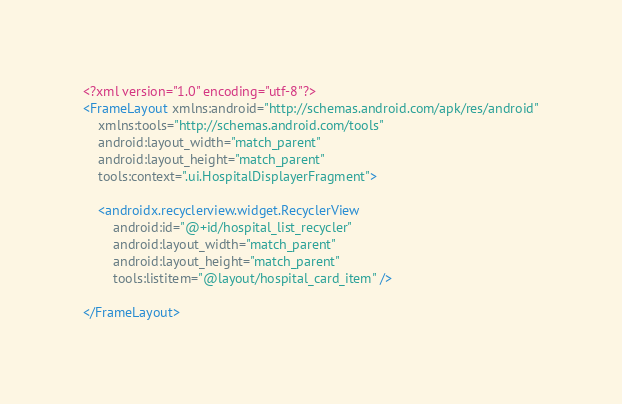Convert code to text. <code><loc_0><loc_0><loc_500><loc_500><_XML_><?xml version="1.0" encoding="utf-8"?>
<FrameLayout xmlns:android="http://schemas.android.com/apk/res/android"
    xmlns:tools="http://schemas.android.com/tools"
    android:layout_width="match_parent"
    android:layout_height="match_parent"
    tools:context=".ui.HospitalDisplayerFragment">

    <androidx.recyclerview.widget.RecyclerView
        android:id="@+id/hospital_list_recycler"
        android:layout_width="match_parent"
        android:layout_height="match_parent"
        tools:listitem="@layout/hospital_card_item" />

</FrameLayout></code> 